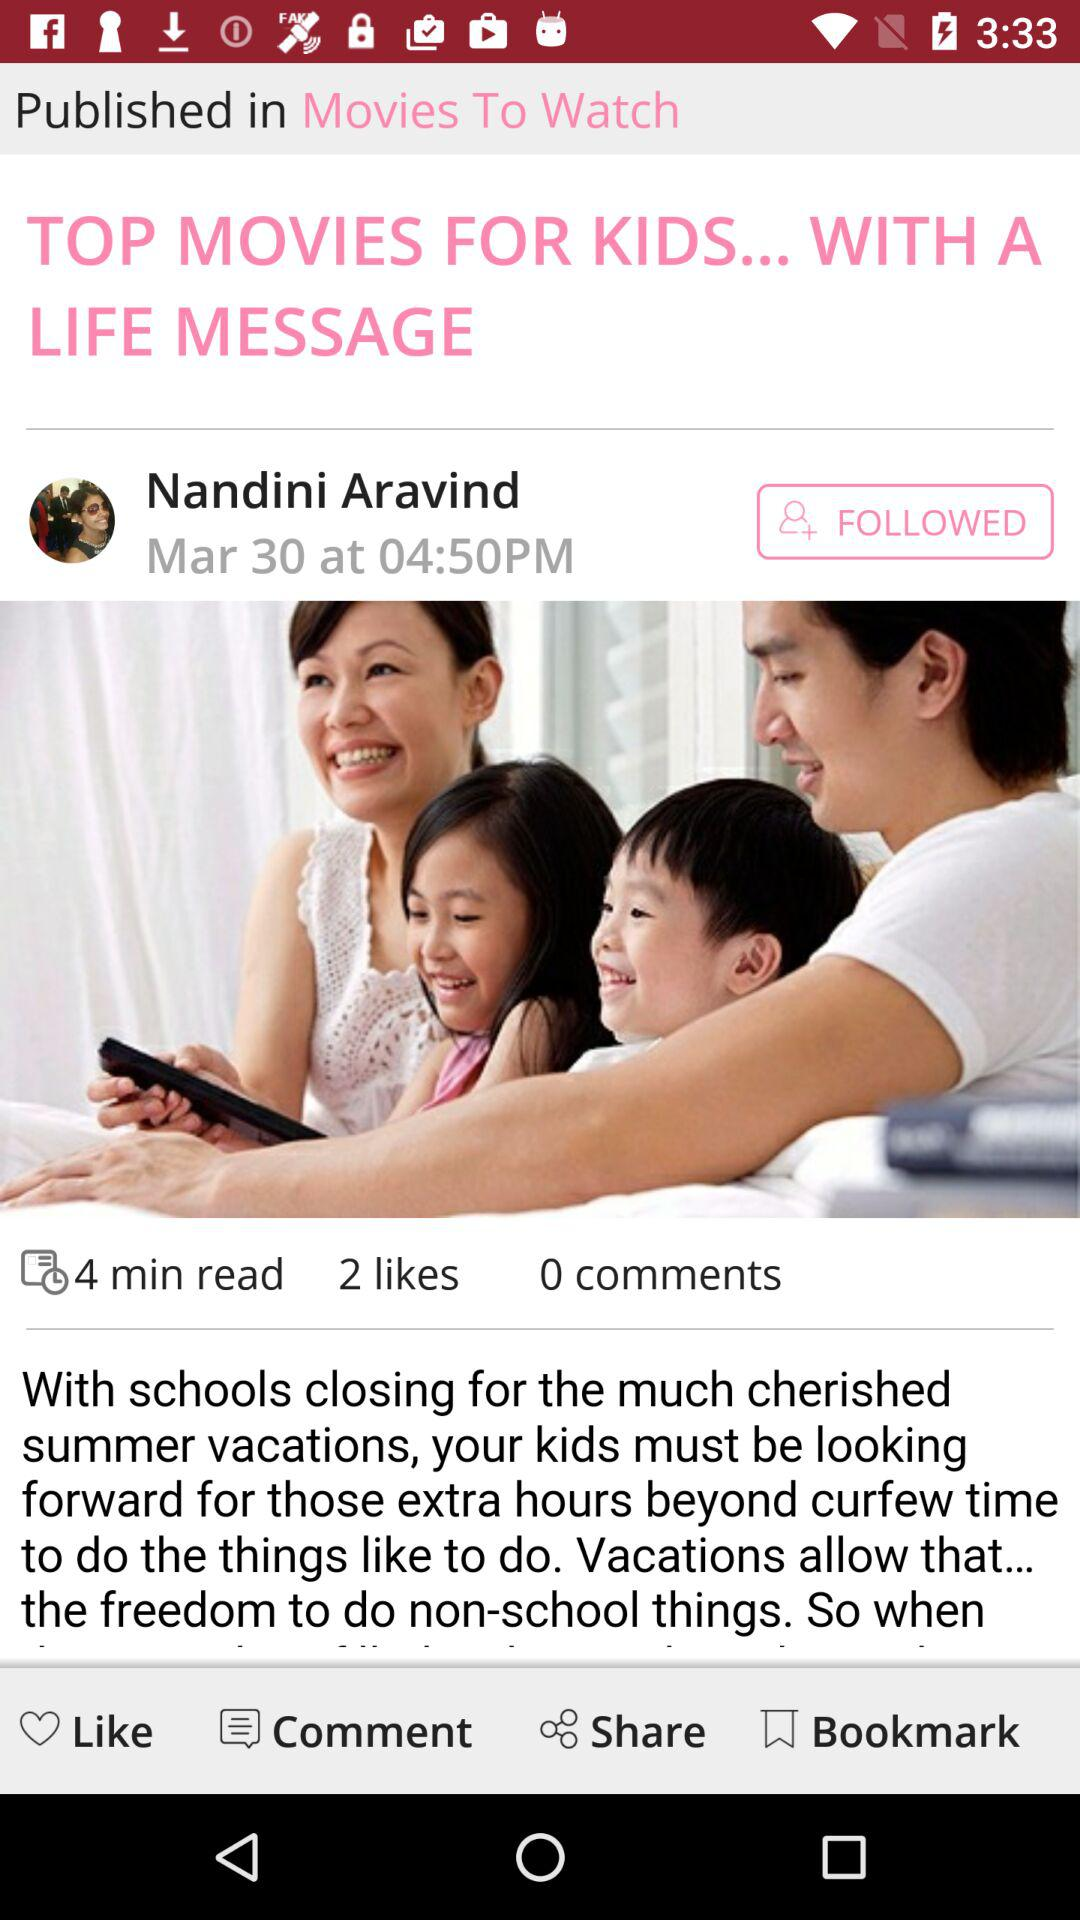What is the author name? The author name is Nandini Aravind. 